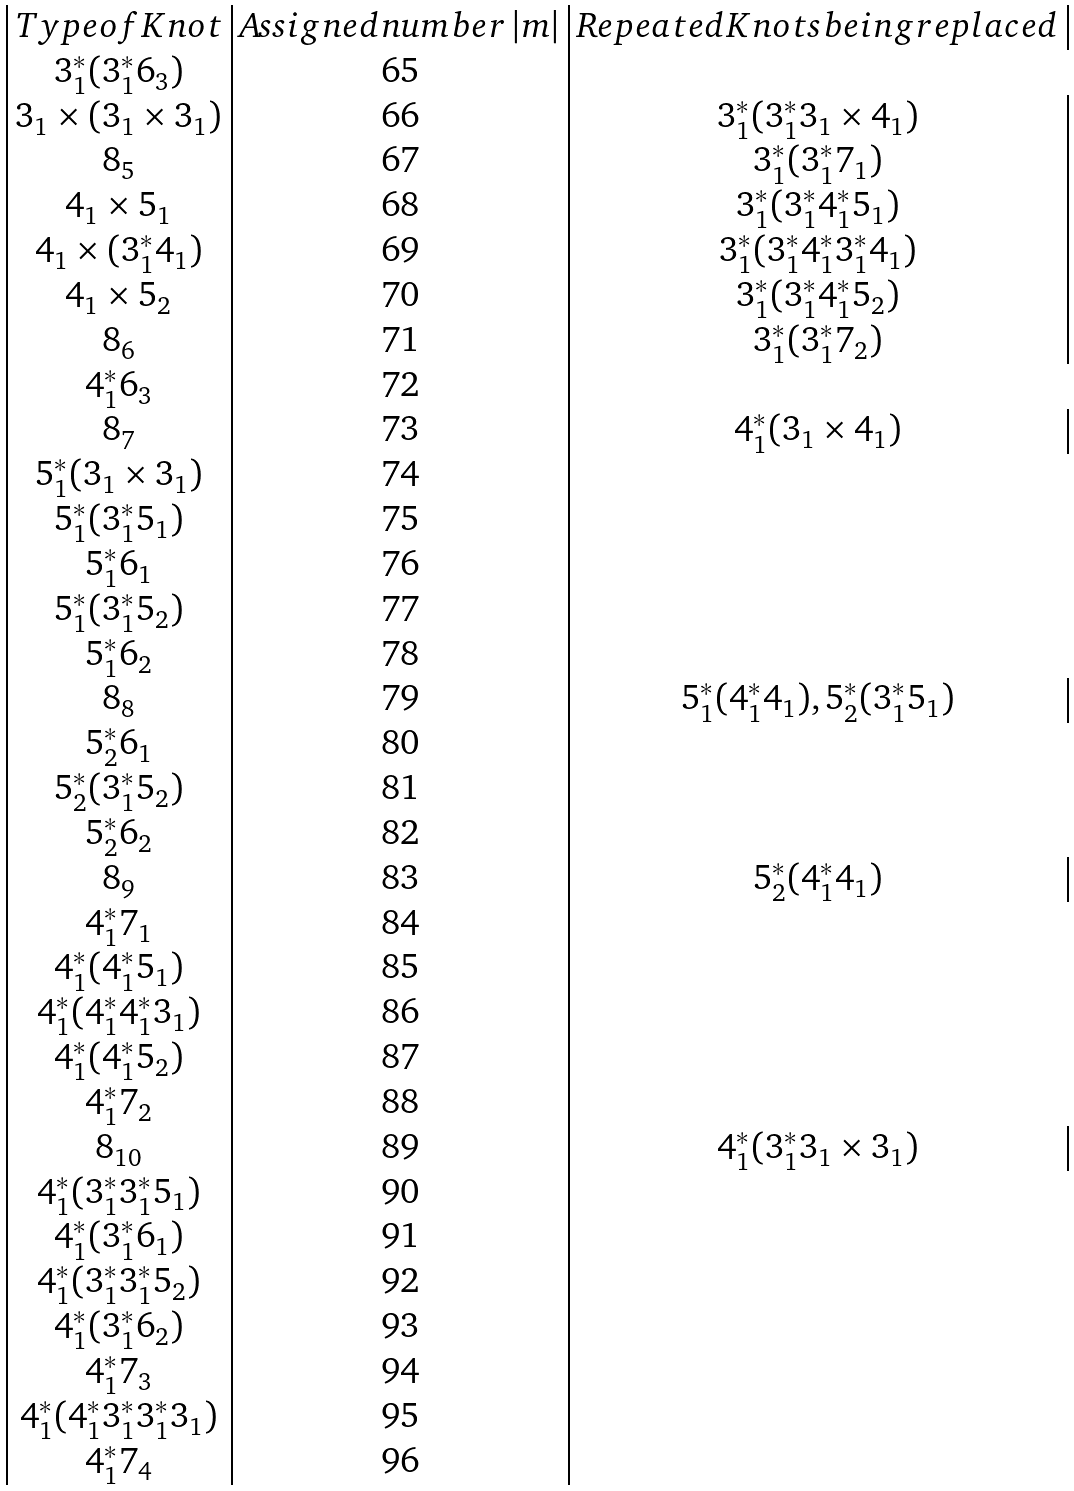Convert formula to latex. <formula><loc_0><loc_0><loc_500><loc_500>\begin{array} { | c | c | c | } T y p e o f K n o t & A s s i g n e d n u m b e r \, | m | & R e p e a t e d K n o t s b e i n g r e p l a c e d \\ { 3 _ { 1 } ^ { * } ( 3 _ { 1 } ^ { * } 6 _ { 3 } ) } & 6 5 \\ { 3 _ { 1 } \times ( 3 _ { 1 } \times 3 _ { 1 } ) } & 6 6 & { 3 _ { 1 } ^ { * } ( 3 _ { 1 } ^ { * } 3 _ { 1 } \times 4 _ { 1 } ) } \\ { 8 _ { 5 } } & 6 7 & { 3 _ { 1 } ^ { * } ( 3 _ { 1 } ^ { * } 7 _ { 1 } ) } \\ { 4 _ { 1 } \times 5 _ { 1 } } & 6 8 & { 3 _ { 1 } ^ { * } ( 3 _ { 1 } ^ { * } 4 _ { 1 } ^ { * } 5 _ { 1 } ) } \\ { 4 _ { 1 } \times ( 3 _ { 1 } ^ { * } 4 _ { 1 } ) } & 6 9 & { 3 _ { 1 } ^ { * } ( 3 _ { 1 } ^ { * } 4 _ { 1 } ^ { * } 3 _ { 1 } ^ { * } 4 _ { 1 } ) } \\ { 4 _ { 1 } \times 5 _ { 2 } } & 7 0 & { 3 _ { 1 } ^ { * } ( 3 _ { 1 } ^ { * } 4 _ { 1 } ^ { * } 5 _ { 2 } ) } \\ { 8 _ { 6 } } & 7 1 & { 3 _ { 1 } ^ { * } ( 3 _ { 1 } ^ { * } 7 _ { 2 } ) } \\ { 4 _ { 1 } ^ { * } 6 _ { 3 } } & 7 2 \\ { 8 _ { 7 } } & 7 3 & { 4 _ { 1 } ^ { * } ( 3 _ { 1 } \times 4 _ { 1 } ) } \\ { 5 _ { 1 } ^ { * } ( 3 _ { 1 } \times 3 _ { 1 } ) } & 7 4 \\ { 5 _ { 1 } ^ { * } ( 3 _ { 1 } ^ { * } 5 _ { 1 } ) } & 7 5 \\ { 5 _ { 1 } ^ { * } 6 _ { 1 } } & 7 6 \\ { 5 _ { 1 } ^ { * } ( 3 _ { 1 } ^ { * } 5 _ { 2 } ) } & 7 7 \\ { 5 _ { 1 } ^ { * } 6 _ { 2 } } & 7 8 \\ { 8 _ { 8 } } & 7 9 & { 5 _ { 1 } ^ { * } ( 4 _ { 1 } ^ { * } 4 _ { 1 } ) , 5 _ { 2 } ^ { * } ( 3 _ { 1 } ^ { * } 5 _ { 1 } ) } \\ { 5 _ { 2 } ^ { * } 6 _ { 1 } } & 8 0 \\ { 5 _ { 2 } ^ { * } ( 3 _ { 1 } ^ { * } 5 _ { 2 } ) } & 8 1 \\ { 5 _ { 2 } ^ { * } 6 _ { 2 } } & 8 2 \\ { 8 _ { 9 } } & 8 3 & { 5 _ { 2 } ^ { * } ( 4 _ { 1 } ^ { * } 4 _ { 1 } ) } \\ { 4 _ { 1 } ^ { * } 7 _ { 1 } } & 8 4 \\ { 4 _ { 1 } ^ { * } ( 4 _ { 1 } ^ { * } 5 _ { 1 } ) } & 8 5 \\ { 4 _ { 1 } ^ { * } ( 4 _ { 1 } ^ { * } 4 _ { 1 } ^ { * } 3 _ { 1 } ) } & 8 6 \\ { 4 _ { 1 } ^ { * } ( 4 _ { 1 } ^ { * } 5 _ { 2 } ) } & 8 7 \\ { 4 _ { 1 } ^ { * } 7 _ { 2 } } & 8 8 \\ { 8 _ { 1 0 } } & 8 9 & { 4 _ { 1 } ^ { * } ( 3 _ { 1 } ^ { * } 3 _ { 1 } \times 3 _ { 1 } ) } \\ { 4 _ { 1 } ^ { * } ( 3 _ { 1 } ^ { * } 3 _ { 1 } ^ { * } 5 _ { 1 } ) } & 9 0 \\ { 4 _ { 1 } ^ { * } ( 3 _ { 1 } ^ { * } 6 _ { 1 } ) } & 9 1 \\ { 4 _ { 1 } ^ { * } ( 3 _ { 1 } ^ { * } 3 _ { 1 } ^ { * } 5 _ { 2 } ) } & 9 2 \\ { 4 _ { 1 } ^ { * } ( 3 _ { 1 } ^ { * } 6 _ { 2 } ) } & 9 3 \\ { 4 _ { 1 } ^ { * } 7 _ { 3 } } & 9 4 \\ { 4 _ { 1 } ^ { * } ( 4 _ { 1 } ^ { * } 3 _ { 1 } ^ { * } 3 _ { 1 } ^ { * } 3 _ { 1 } ) } & 9 5 \\ { 4 _ { 1 } ^ { * } 7 _ { 4 } } & 9 6 \\ \end{array}</formula> 